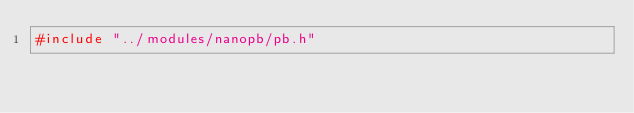<code> <loc_0><loc_0><loc_500><loc_500><_C_>#include "../modules/nanopb/pb.h"</code> 